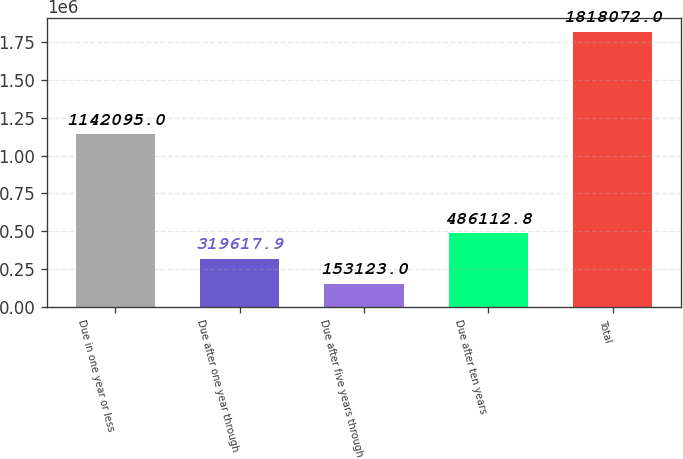<chart> <loc_0><loc_0><loc_500><loc_500><bar_chart><fcel>Due in one year or less<fcel>Due after one year through<fcel>Due after five years through<fcel>Due after ten years<fcel>Total<nl><fcel>1.1421e+06<fcel>319618<fcel>153123<fcel>486113<fcel>1.81807e+06<nl></chart> 